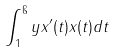<formula> <loc_0><loc_0><loc_500><loc_500>\int _ { 1 } ^ { \i } y x ^ { \prime } ( t ) x ( t ) d t</formula> 